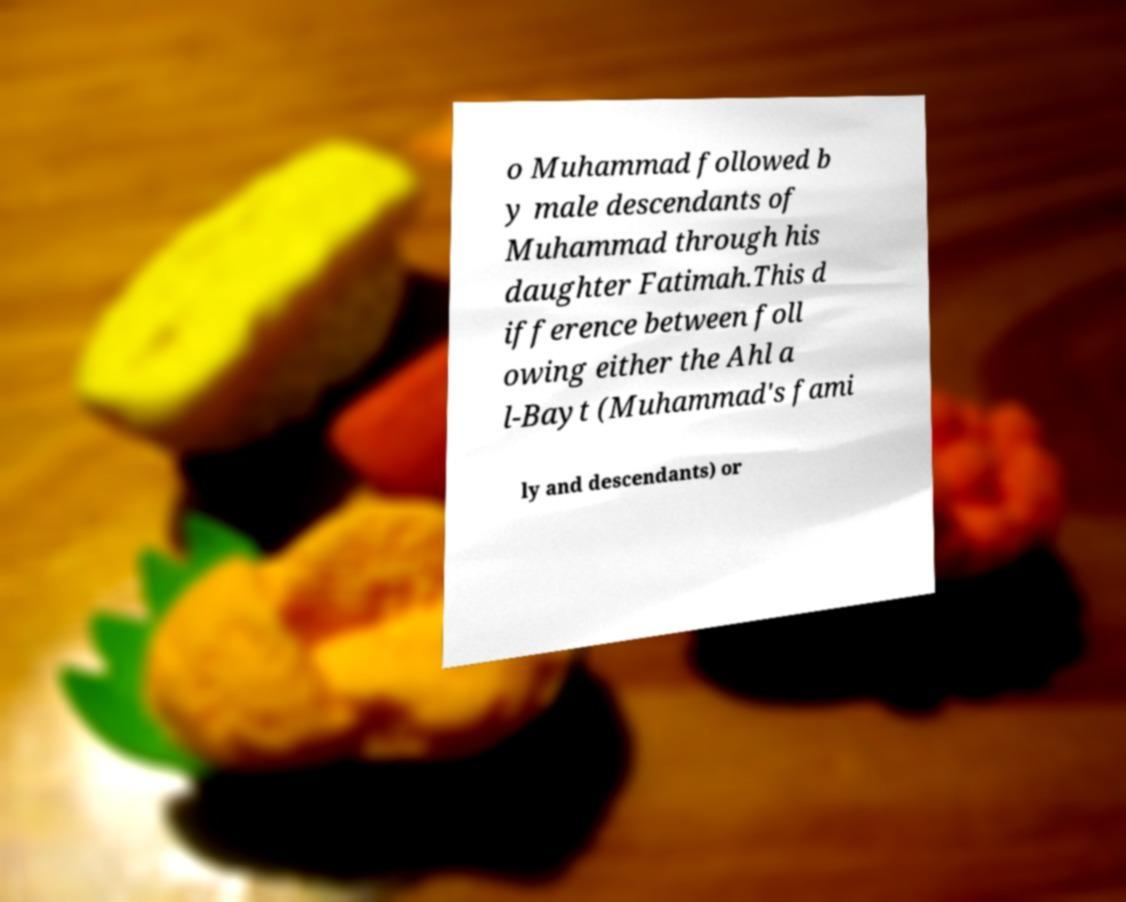For documentation purposes, I need the text within this image transcribed. Could you provide that? o Muhammad followed b y male descendants of Muhammad through his daughter Fatimah.This d ifference between foll owing either the Ahl a l-Bayt (Muhammad's fami ly and descendants) or 